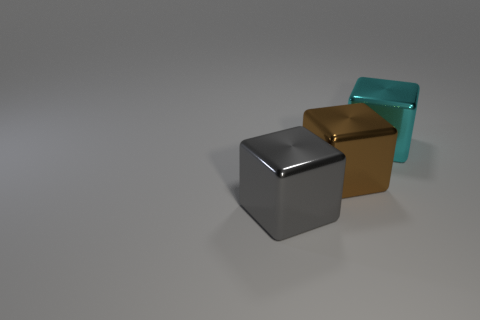Add 2 cyan objects. How many objects exist? 5 Subtract all yellow metal cylinders. Subtract all cyan shiny objects. How many objects are left? 2 Add 3 large gray metallic blocks. How many large gray metallic blocks are left? 4 Add 1 cyan metallic things. How many cyan metallic things exist? 2 Subtract 0 purple blocks. How many objects are left? 3 Subtract all purple cubes. Subtract all brown balls. How many cubes are left? 3 